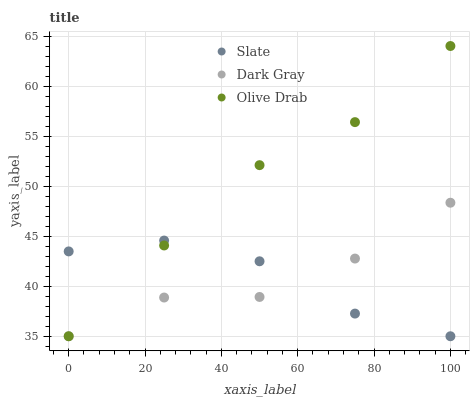Does Dark Gray have the minimum area under the curve?
Answer yes or no. Yes. Does Olive Drab have the maximum area under the curve?
Answer yes or no. Yes. Does Slate have the minimum area under the curve?
Answer yes or no. No. Does Slate have the maximum area under the curve?
Answer yes or no. No. Is Olive Drab the smoothest?
Answer yes or no. Yes. Is Dark Gray the roughest?
Answer yes or no. Yes. Is Slate the smoothest?
Answer yes or no. No. Is Slate the roughest?
Answer yes or no. No. Does Dark Gray have the lowest value?
Answer yes or no. Yes. Does Olive Drab have the highest value?
Answer yes or no. Yes. Does Slate have the highest value?
Answer yes or no. No. Does Olive Drab intersect Slate?
Answer yes or no. Yes. Is Olive Drab less than Slate?
Answer yes or no. No. Is Olive Drab greater than Slate?
Answer yes or no. No. 